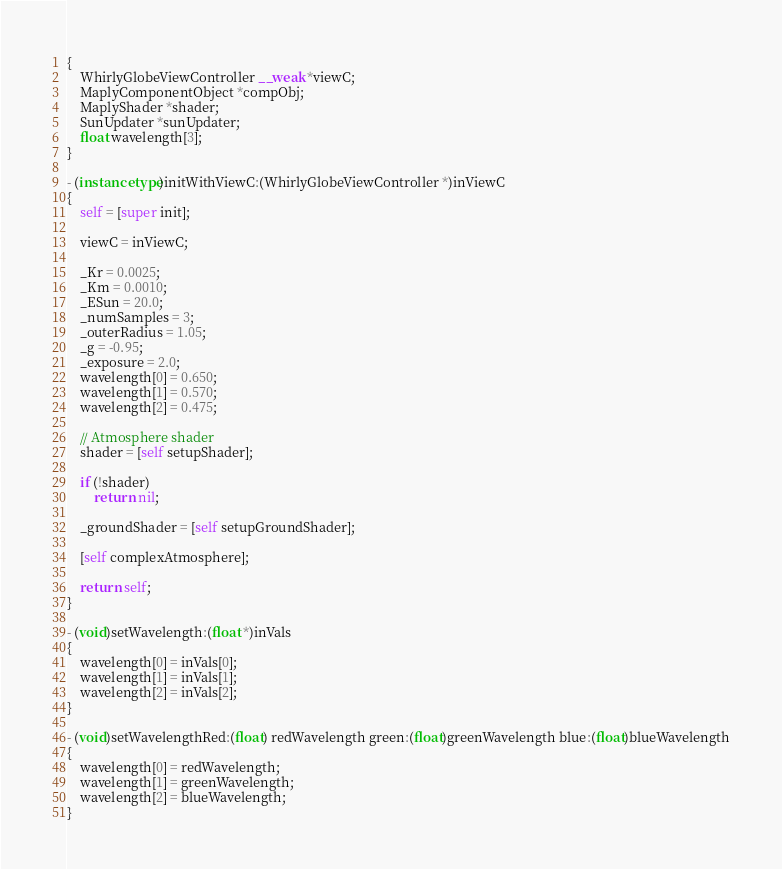Convert code to text. <code><loc_0><loc_0><loc_500><loc_500><_ObjectiveC_>{
    WhirlyGlobeViewController __weak *viewC;
    MaplyComponentObject *compObj;
    MaplyShader *shader;
    SunUpdater *sunUpdater;
    float wavelength[3];
}

- (instancetype)initWithViewC:(WhirlyGlobeViewController *)inViewC
{
    self = [super init];
    
    viewC = inViewC;
    
    _Kr = 0.0025;
    _Km = 0.0010;
    _ESun = 20.0;
    _numSamples = 3;
    _outerRadius = 1.05;
    _g = -0.95;
    _exposure = 2.0;
    wavelength[0] = 0.650;
    wavelength[1] = 0.570;
    wavelength[2] = 0.475;

    // Atmosphere shader
    shader = [self setupShader];
    
    if (!shader)
        return nil;
    
    _groundShader = [self setupGroundShader];

    [self complexAtmosphere];
    
    return self;
}

- (void)setWavelength:(float *)inVals
{
    wavelength[0] = inVals[0];
    wavelength[1] = inVals[1];
    wavelength[2] = inVals[2];
}

- (void)setWavelengthRed:(float) redWavelength green:(float)greenWavelength blue:(float)blueWavelength
{
    wavelength[0] = redWavelength;
    wavelength[1] = greenWavelength;
    wavelength[2] = blueWavelength;
}
</code> 